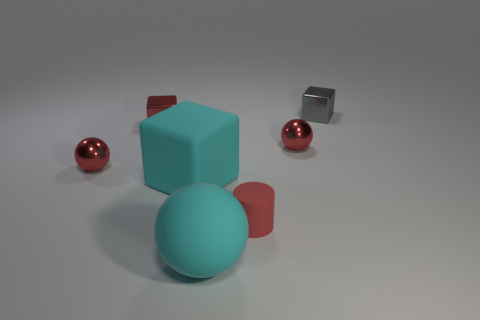Is there any other thing that is the same size as the gray object?
Ensure brevity in your answer.  Yes. Do the cyan rubber sphere and the red thing that is in front of the rubber cube have the same size?
Make the answer very short. No. There is a shiny block in front of the gray metallic cube; does it have the same size as the gray thing?
Provide a short and direct response. Yes. How many other objects are the same material as the red block?
Give a very brief answer. 3. Are there an equal number of red shiny balls that are in front of the red cylinder and red spheres that are on the right side of the red block?
Offer a terse response. No. What is the color of the small rubber object in front of the small red shiny ball that is left of the rubber thing behind the small matte cylinder?
Offer a very short reply. Red. What shape is the small metallic object to the left of the red block?
Your answer should be very brief. Sphere. There is a big thing that is the same material as the big block; what shape is it?
Give a very brief answer. Sphere. Is there anything else that is the same shape as the gray object?
Ensure brevity in your answer.  Yes. How many tiny red things are left of the large matte ball?
Provide a short and direct response. 2. 